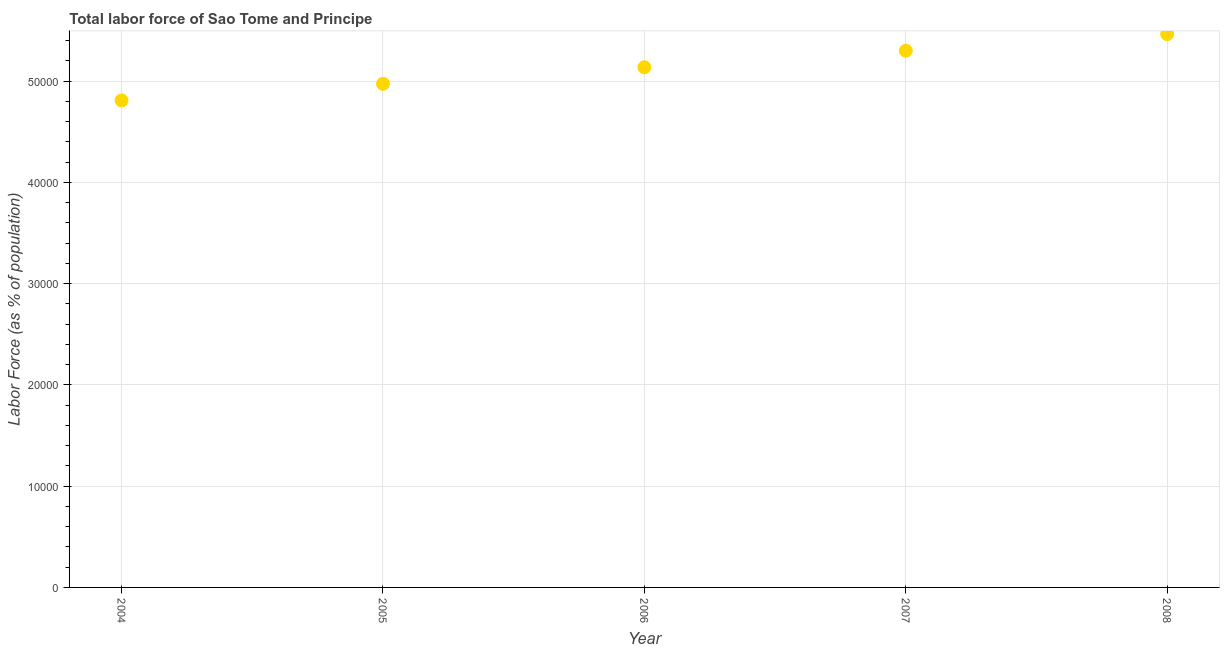What is the total labor force in 2006?
Your response must be concise. 5.14e+04. Across all years, what is the maximum total labor force?
Your answer should be very brief. 5.46e+04. Across all years, what is the minimum total labor force?
Make the answer very short. 4.81e+04. What is the sum of the total labor force?
Provide a short and direct response. 2.57e+05. What is the difference between the total labor force in 2004 and 2007?
Your answer should be very brief. -4906. What is the average total labor force per year?
Make the answer very short. 5.14e+04. What is the median total labor force?
Keep it short and to the point. 5.14e+04. Do a majority of the years between 2005 and 2008 (inclusive) have total labor force greater than 16000 %?
Ensure brevity in your answer.  Yes. What is the ratio of the total labor force in 2006 to that in 2008?
Your response must be concise. 0.94. Is the total labor force in 2004 less than that in 2008?
Make the answer very short. Yes. Is the difference between the total labor force in 2006 and 2008 greater than the difference between any two years?
Offer a terse response. No. What is the difference between the highest and the second highest total labor force?
Your answer should be very brief. 1638. What is the difference between the highest and the lowest total labor force?
Ensure brevity in your answer.  6544. Does the total labor force monotonically increase over the years?
Provide a short and direct response. Yes. How many dotlines are there?
Keep it short and to the point. 1. What is the difference between two consecutive major ticks on the Y-axis?
Provide a succinct answer. 10000. Are the values on the major ticks of Y-axis written in scientific E-notation?
Offer a terse response. No. Does the graph contain grids?
Keep it short and to the point. Yes. What is the title of the graph?
Provide a short and direct response. Total labor force of Sao Tome and Principe. What is the label or title of the X-axis?
Give a very brief answer. Year. What is the label or title of the Y-axis?
Your answer should be compact. Labor Force (as % of population). What is the Labor Force (as % of population) in 2004?
Your answer should be compact. 4.81e+04. What is the Labor Force (as % of population) in 2005?
Offer a very short reply. 4.97e+04. What is the Labor Force (as % of population) in 2006?
Give a very brief answer. 5.14e+04. What is the Labor Force (as % of population) in 2007?
Your answer should be very brief. 5.30e+04. What is the Labor Force (as % of population) in 2008?
Provide a succinct answer. 5.46e+04. What is the difference between the Labor Force (as % of population) in 2004 and 2005?
Make the answer very short. -1641. What is the difference between the Labor Force (as % of population) in 2004 and 2006?
Ensure brevity in your answer.  -3274. What is the difference between the Labor Force (as % of population) in 2004 and 2007?
Your response must be concise. -4906. What is the difference between the Labor Force (as % of population) in 2004 and 2008?
Give a very brief answer. -6544. What is the difference between the Labor Force (as % of population) in 2005 and 2006?
Make the answer very short. -1633. What is the difference between the Labor Force (as % of population) in 2005 and 2007?
Offer a terse response. -3265. What is the difference between the Labor Force (as % of population) in 2005 and 2008?
Keep it short and to the point. -4903. What is the difference between the Labor Force (as % of population) in 2006 and 2007?
Ensure brevity in your answer.  -1632. What is the difference between the Labor Force (as % of population) in 2006 and 2008?
Provide a short and direct response. -3270. What is the difference between the Labor Force (as % of population) in 2007 and 2008?
Offer a terse response. -1638. What is the ratio of the Labor Force (as % of population) in 2004 to that in 2006?
Keep it short and to the point. 0.94. What is the ratio of the Labor Force (as % of population) in 2004 to that in 2007?
Ensure brevity in your answer.  0.91. What is the ratio of the Labor Force (as % of population) in 2004 to that in 2008?
Provide a short and direct response. 0.88. What is the ratio of the Labor Force (as % of population) in 2005 to that in 2006?
Your answer should be compact. 0.97. What is the ratio of the Labor Force (as % of population) in 2005 to that in 2007?
Your answer should be very brief. 0.94. What is the ratio of the Labor Force (as % of population) in 2005 to that in 2008?
Offer a very short reply. 0.91. What is the ratio of the Labor Force (as % of population) in 2006 to that in 2007?
Your answer should be compact. 0.97. 